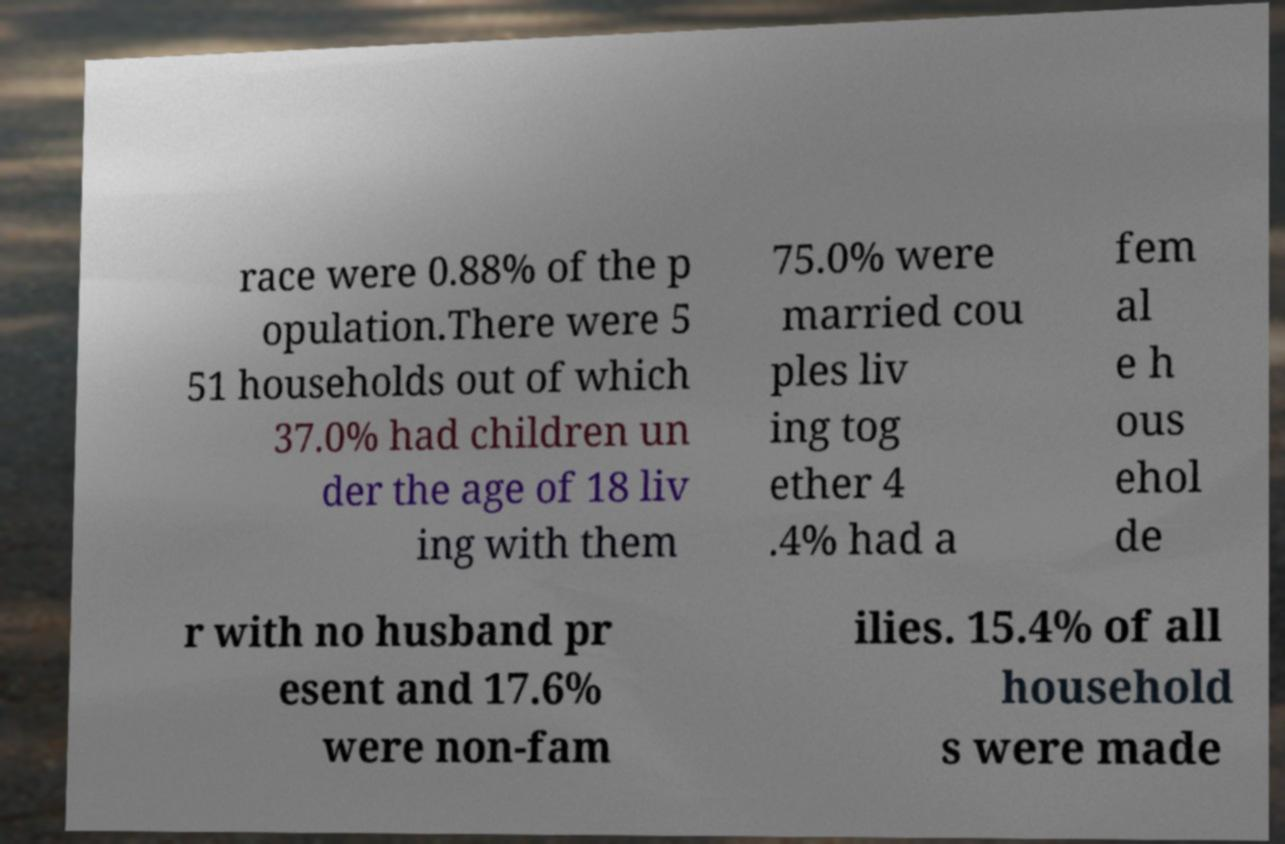I need the written content from this picture converted into text. Can you do that? race were 0.88% of the p opulation.There were 5 51 households out of which 37.0% had children un der the age of 18 liv ing with them 75.0% were married cou ples liv ing tog ether 4 .4% had a fem al e h ous ehol de r with no husband pr esent and 17.6% were non-fam ilies. 15.4% of all household s were made 